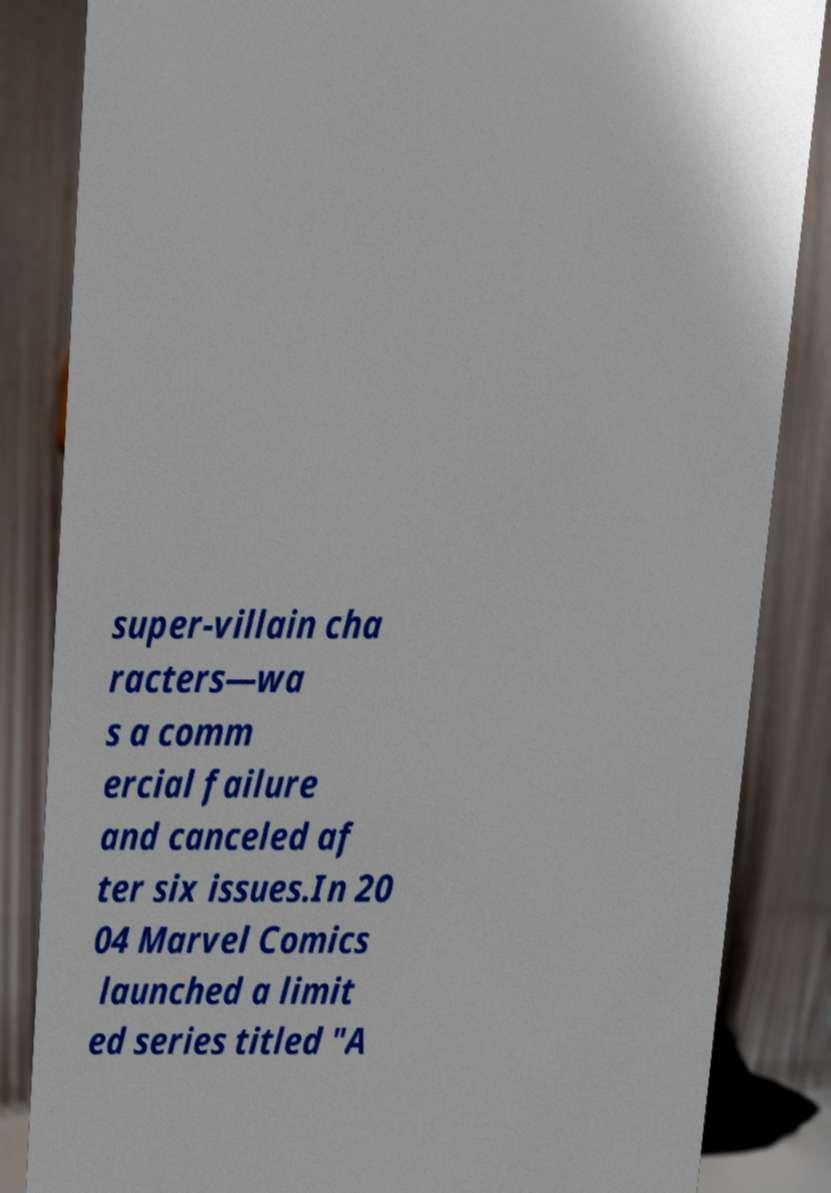There's text embedded in this image that I need extracted. Can you transcribe it verbatim? super-villain cha racters—wa s a comm ercial failure and canceled af ter six issues.In 20 04 Marvel Comics launched a limit ed series titled "A 